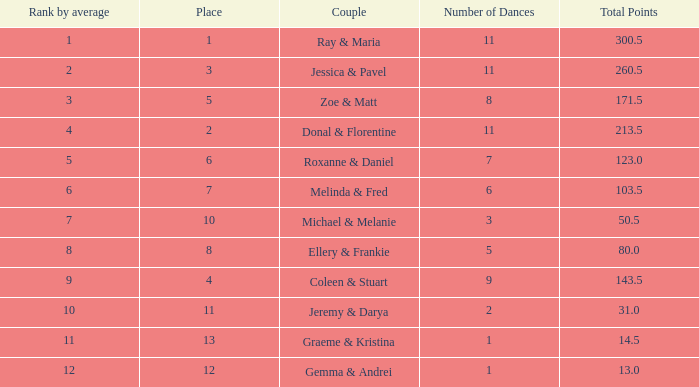0? 1.0. Could you help me parse every detail presented in this table? {'header': ['Rank by average', 'Place', 'Couple', 'Number of Dances', 'Total Points'], 'rows': [['1', '1', 'Ray & Maria', '11', '300.5'], ['2', '3', 'Jessica & Pavel', '11', '260.5'], ['3', '5', 'Zoe & Matt', '8', '171.5'], ['4', '2', 'Donal & Florentine', '11', '213.5'], ['5', '6', 'Roxanne & Daniel', '7', '123.0'], ['6', '7', 'Melinda & Fred', '6', '103.5'], ['7', '10', 'Michael & Melanie', '3', '50.5'], ['8', '8', 'Ellery & Frankie', '5', '80.0'], ['9', '4', 'Coleen & Stuart', '9', '143.5'], ['10', '11', 'Jeremy & Darya', '2', '31.0'], ['11', '13', 'Graeme & Kristina', '1', '14.5'], ['12', '12', 'Gemma & Andrei', '1', '13.0']]} 